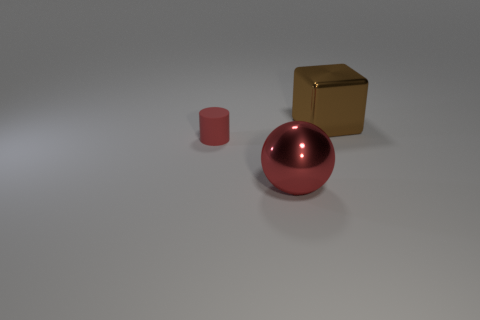Add 2 green metal balls. How many objects exist? 5 Subtract all green blocks. How many green balls are left? 0 Add 1 balls. How many balls are left? 2 Add 3 tiny blue matte things. How many tiny blue matte things exist? 3 Subtract 1 brown blocks. How many objects are left? 2 Subtract all red spheres. Subtract all small rubber objects. How many objects are left? 1 